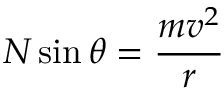Convert formula to latex. <formula><loc_0><loc_0><loc_500><loc_500>N \sin \theta = { \frac { m v ^ { 2 } } { r } }</formula> 